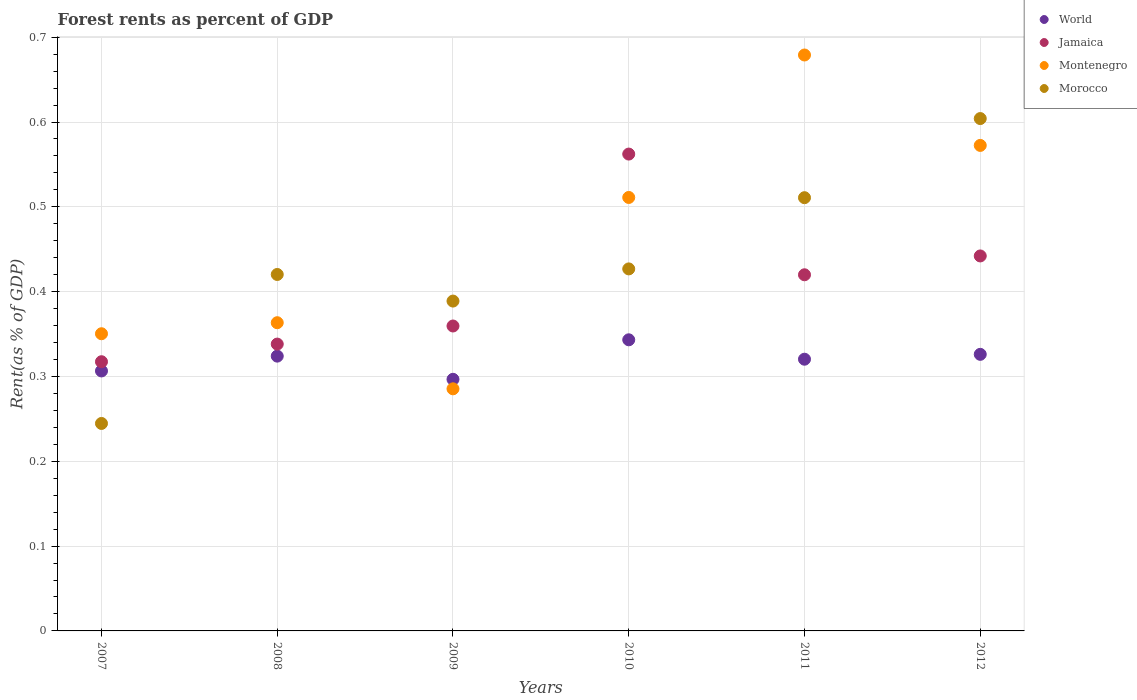How many different coloured dotlines are there?
Provide a succinct answer. 4. What is the forest rent in World in 2011?
Provide a succinct answer. 0.32. Across all years, what is the maximum forest rent in Jamaica?
Give a very brief answer. 0.56. Across all years, what is the minimum forest rent in Morocco?
Make the answer very short. 0.24. In which year was the forest rent in World minimum?
Offer a very short reply. 2009. What is the total forest rent in Jamaica in the graph?
Provide a short and direct response. 2.44. What is the difference between the forest rent in Jamaica in 2011 and that in 2012?
Your answer should be compact. -0.02. What is the difference between the forest rent in Montenegro in 2011 and the forest rent in Jamaica in 2010?
Make the answer very short. 0.12. What is the average forest rent in Morocco per year?
Offer a terse response. 0.43. In the year 2009, what is the difference between the forest rent in Montenegro and forest rent in World?
Ensure brevity in your answer.  -0.01. What is the ratio of the forest rent in World in 2007 to that in 2011?
Offer a very short reply. 0.96. Is the difference between the forest rent in Montenegro in 2008 and 2012 greater than the difference between the forest rent in World in 2008 and 2012?
Offer a very short reply. No. What is the difference between the highest and the second highest forest rent in World?
Provide a succinct answer. 0.02. What is the difference between the highest and the lowest forest rent in Jamaica?
Your answer should be compact. 0.24. Is it the case that in every year, the sum of the forest rent in World and forest rent in Montenegro  is greater than the sum of forest rent in Jamaica and forest rent in Morocco?
Give a very brief answer. No. Is it the case that in every year, the sum of the forest rent in Morocco and forest rent in Jamaica  is greater than the forest rent in Montenegro?
Provide a short and direct response. Yes. Is the forest rent in Morocco strictly greater than the forest rent in World over the years?
Offer a very short reply. No. Is the forest rent in Morocco strictly less than the forest rent in World over the years?
Offer a very short reply. No. How many dotlines are there?
Provide a short and direct response. 4. How many years are there in the graph?
Your answer should be very brief. 6. Does the graph contain grids?
Your answer should be very brief. Yes. What is the title of the graph?
Offer a terse response. Forest rents as percent of GDP. What is the label or title of the Y-axis?
Provide a short and direct response. Rent(as % of GDP). What is the Rent(as % of GDP) in World in 2007?
Your response must be concise. 0.31. What is the Rent(as % of GDP) of Jamaica in 2007?
Your answer should be very brief. 0.32. What is the Rent(as % of GDP) in Montenegro in 2007?
Keep it short and to the point. 0.35. What is the Rent(as % of GDP) of Morocco in 2007?
Keep it short and to the point. 0.24. What is the Rent(as % of GDP) in World in 2008?
Give a very brief answer. 0.32. What is the Rent(as % of GDP) in Jamaica in 2008?
Provide a succinct answer. 0.34. What is the Rent(as % of GDP) in Montenegro in 2008?
Give a very brief answer. 0.36. What is the Rent(as % of GDP) of Morocco in 2008?
Provide a short and direct response. 0.42. What is the Rent(as % of GDP) in World in 2009?
Give a very brief answer. 0.3. What is the Rent(as % of GDP) of Jamaica in 2009?
Provide a short and direct response. 0.36. What is the Rent(as % of GDP) in Montenegro in 2009?
Keep it short and to the point. 0.29. What is the Rent(as % of GDP) of Morocco in 2009?
Your response must be concise. 0.39. What is the Rent(as % of GDP) in World in 2010?
Your answer should be compact. 0.34. What is the Rent(as % of GDP) in Jamaica in 2010?
Make the answer very short. 0.56. What is the Rent(as % of GDP) of Montenegro in 2010?
Offer a very short reply. 0.51. What is the Rent(as % of GDP) of Morocco in 2010?
Provide a short and direct response. 0.43. What is the Rent(as % of GDP) of World in 2011?
Provide a short and direct response. 0.32. What is the Rent(as % of GDP) of Jamaica in 2011?
Give a very brief answer. 0.42. What is the Rent(as % of GDP) in Montenegro in 2011?
Your answer should be very brief. 0.68. What is the Rent(as % of GDP) in Morocco in 2011?
Provide a succinct answer. 0.51. What is the Rent(as % of GDP) of World in 2012?
Offer a terse response. 0.33. What is the Rent(as % of GDP) in Jamaica in 2012?
Your answer should be compact. 0.44. What is the Rent(as % of GDP) in Montenegro in 2012?
Offer a very short reply. 0.57. What is the Rent(as % of GDP) of Morocco in 2012?
Your answer should be compact. 0.6. Across all years, what is the maximum Rent(as % of GDP) of World?
Your response must be concise. 0.34. Across all years, what is the maximum Rent(as % of GDP) in Jamaica?
Keep it short and to the point. 0.56. Across all years, what is the maximum Rent(as % of GDP) of Montenegro?
Provide a succinct answer. 0.68. Across all years, what is the maximum Rent(as % of GDP) of Morocco?
Ensure brevity in your answer.  0.6. Across all years, what is the minimum Rent(as % of GDP) in World?
Provide a succinct answer. 0.3. Across all years, what is the minimum Rent(as % of GDP) of Jamaica?
Your response must be concise. 0.32. Across all years, what is the minimum Rent(as % of GDP) in Montenegro?
Make the answer very short. 0.29. Across all years, what is the minimum Rent(as % of GDP) in Morocco?
Provide a succinct answer. 0.24. What is the total Rent(as % of GDP) of World in the graph?
Your answer should be very brief. 1.92. What is the total Rent(as % of GDP) in Jamaica in the graph?
Your answer should be very brief. 2.44. What is the total Rent(as % of GDP) in Montenegro in the graph?
Provide a succinct answer. 2.76. What is the total Rent(as % of GDP) of Morocco in the graph?
Make the answer very short. 2.6. What is the difference between the Rent(as % of GDP) in World in 2007 and that in 2008?
Keep it short and to the point. -0.02. What is the difference between the Rent(as % of GDP) in Jamaica in 2007 and that in 2008?
Provide a short and direct response. -0.02. What is the difference between the Rent(as % of GDP) in Montenegro in 2007 and that in 2008?
Your answer should be very brief. -0.01. What is the difference between the Rent(as % of GDP) in Morocco in 2007 and that in 2008?
Your response must be concise. -0.18. What is the difference between the Rent(as % of GDP) in World in 2007 and that in 2009?
Your response must be concise. 0.01. What is the difference between the Rent(as % of GDP) of Jamaica in 2007 and that in 2009?
Offer a very short reply. -0.04. What is the difference between the Rent(as % of GDP) of Montenegro in 2007 and that in 2009?
Offer a terse response. 0.06. What is the difference between the Rent(as % of GDP) in Morocco in 2007 and that in 2009?
Make the answer very short. -0.14. What is the difference between the Rent(as % of GDP) in World in 2007 and that in 2010?
Your answer should be compact. -0.04. What is the difference between the Rent(as % of GDP) of Jamaica in 2007 and that in 2010?
Ensure brevity in your answer.  -0.24. What is the difference between the Rent(as % of GDP) of Montenegro in 2007 and that in 2010?
Provide a succinct answer. -0.16. What is the difference between the Rent(as % of GDP) in Morocco in 2007 and that in 2010?
Offer a terse response. -0.18. What is the difference between the Rent(as % of GDP) in World in 2007 and that in 2011?
Ensure brevity in your answer.  -0.01. What is the difference between the Rent(as % of GDP) in Jamaica in 2007 and that in 2011?
Your response must be concise. -0.1. What is the difference between the Rent(as % of GDP) in Montenegro in 2007 and that in 2011?
Offer a terse response. -0.33. What is the difference between the Rent(as % of GDP) of Morocco in 2007 and that in 2011?
Your answer should be very brief. -0.27. What is the difference between the Rent(as % of GDP) in World in 2007 and that in 2012?
Your answer should be very brief. -0.02. What is the difference between the Rent(as % of GDP) in Jamaica in 2007 and that in 2012?
Make the answer very short. -0.12. What is the difference between the Rent(as % of GDP) of Montenegro in 2007 and that in 2012?
Provide a succinct answer. -0.22. What is the difference between the Rent(as % of GDP) of Morocco in 2007 and that in 2012?
Offer a very short reply. -0.36. What is the difference between the Rent(as % of GDP) of World in 2008 and that in 2009?
Keep it short and to the point. 0.03. What is the difference between the Rent(as % of GDP) in Jamaica in 2008 and that in 2009?
Provide a short and direct response. -0.02. What is the difference between the Rent(as % of GDP) in Montenegro in 2008 and that in 2009?
Offer a terse response. 0.08. What is the difference between the Rent(as % of GDP) in Morocco in 2008 and that in 2009?
Offer a very short reply. 0.03. What is the difference between the Rent(as % of GDP) of World in 2008 and that in 2010?
Your response must be concise. -0.02. What is the difference between the Rent(as % of GDP) in Jamaica in 2008 and that in 2010?
Provide a short and direct response. -0.22. What is the difference between the Rent(as % of GDP) in Montenegro in 2008 and that in 2010?
Ensure brevity in your answer.  -0.15. What is the difference between the Rent(as % of GDP) in Morocco in 2008 and that in 2010?
Offer a very short reply. -0.01. What is the difference between the Rent(as % of GDP) in World in 2008 and that in 2011?
Make the answer very short. 0. What is the difference between the Rent(as % of GDP) in Jamaica in 2008 and that in 2011?
Provide a short and direct response. -0.08. What is the difference between the Rent(as % of GDP) of Montenegro in 2008 and that in 2011?
Provide a short and direct response. -0.32. What is the difference between the Rent(as % of GDP) of Morocco in 2008 and that in 2011?
Your answer should be very brief. -0.09. What is the difference between the Rent(as % of GDP) of World in 2008 and that in 2012?
Provide a short and direct response. -0. What is the difference between the Rent(as % of GDP) of Jamaica in 2008 and that in 2012?
Ensure brevity in your answer.  -0.1. What is the difference between the Rent(as % of GDP) of Montenegro in 2008 and that in 2012?
Give a very brief answer. -0.21. What is the difference between the Rent(as % of GDP) in Morocco in 2008 and that in 2012?
Make the answer very short. -0.18. What is the difference between the Rent(as % of GDP) in World in 2009 and that in 2010?
Offer a terse response. -0.05. What is the difference between the Rent(as % of GDP) of Jamaica in 2009 and that in 2010?
Your answer should be very brief. -0.2. What is the difference between the Rent(as % of GDP) in Montenegro in 2009 and that in 2010?
Provide a short and direct response. -0.23. What is the difference between the Rent(as % of GDP) of Morocco in 2009 and that in 2010?
Ensure brevity in your answer.  -0.04. What is the difference between the Rent(as % of GDP) of World in 2009 and that in 2011?
Your answer should be very brief. -0.02. What is the difference between the Rent(as % of GDP) in Jamaica in 2009 and that in 2011?
Ensure brevity in your answer.  -0.06. What is the difference between the Rent(as % of GDP) of Montenegro in 2009 and that in 2011?
Give a very brief answer. -0.39. What is the difference between the Rent(as % of GDP) of Morocco in 2009 and that in 2011?
Make the answer very short. -0.12. What is the difference between the Rent(as % of GDP) of World in 2009 and that in 2012?
Make the answer very short. -0.03. What is the difference between the Rent(as % of GDP) in Jamaica in 2009 and that in 2012?
Ensure brevity in your answer.  -0.08. What is the difference between the Rent(as % of GDP) in Montenegro in 2009 and that in 2012?
Offer a terse response. -0.29. What is the difference between the Rent(as % of GDP) of Morocco in 2009 and that in 2012?
Ensure brevity in your answer.  -0.22. What is the difference between the Rent(as % of GDP) in World in 2010 and that in 2011?
Your answer should be compact. 0.02. What is the difference between the Rent(as % of GDP) of Jamaica in 2010 and that in 2011?
Your response must be concise. 0.14. What is the difference between the Rent(as % of GDP) in Montenegro in 2010 and that in 2011?
Provide a short and direct response. -0.17. What is the difference between the Rent(as % of GDP) of Morocco in 2010 and that in 2011?
Give a very brief answer. -0.08. What is the difference between the Rent(as % of GDP) in World in 2010 and that in 2012?
Offer a very short reply. 0.02. What is the difference between the Rent(as % of GDP) in Jamaica in 2010 and that in 2012?
Ensure brevity in your answer.  0.12. What is the difference between the Rent(as % of GDP) in Montenegro in 2010 and that in 2012?
Offer a very short reply. -0.06. What is the difference between the Rent(as % of GDP) in Morocco in 2010 and that in 2012?
Provide a succinct answer. -0.18. What is the difference between the Rent(as % of GDP) of World in 2011 and that in 2012?
Keep it short and to the point. -0.01. What is the difference between the Rent(as % of GDP) of Jamaica in 2011 and that in 2012?
Provide a succinct answer. -0.02. What is the difference between the Rent(as % of GDP) of Montenegro in 2011 and that in 2012?
Offer a terse response. 0.11. What is the difference between the Rent(as % of GDP) in Morocco in 2011 and that in 2012?
Offer a terse response. -0.09. What is the difference between the Rent(as % of GDP) of World in 2007 and the Rent(as % of GDP) of Jamaica in 2008?
Your response must be concise. -0.03. What is the difference between the Rent(as % of GDP) in World in 2007 and the Rent(as % of GDP) in Montenegro in 2008?
Your answer should be compact. -0.06. What is the difference between the Rent(as % of GDP) of World in 2007 and the Rent(as % of GDP) of Morocco in 2008?
Offer a terse response. -0.11. What is the difference between the Rent(as % of GDP) in Jamaica in 2007 and the Rent(as % of GDP) in Montenegro in 2008?
Your response must be concise. -0.05. What is the difference between the Rent(as % of GDP) of Jamaica in 2007 and the Rent(as % of GDP) of Morocco in 2008?
Make the answer very short. -0.1. What is the difference between the Rent(as % of GDP) in Montenegro in 2007 and the Rent(as % of GDP) in Morocco in 2008?
Your answer should be compact. -0.07. What is the difference between the Rent(as % of GDP) of World in 2007 and the Rent(as % of GDP) of Jamaica in 2009?
Provide a succinct answer. -0.05. What is the difference between the Rent(as % of GDP) of World in 2007 and the Rent(as % of GDP) of Montenegro in 2009?
Keep it short and to the point. 0.02. What is the difference between the Rent(as % of GDP) of World in 2007 and the Rent(as % of GDP) of Morocco in 2009?
Offer a very short reply. -0.08. What is the difference between the Rent(as % of GDP) in Jamaica in 2007 and the Rent(as % of GDP) in Montenegro in 2009?
Your response must be concise. 0.03. What is the difference between the Rent(as % of GDP) in Jamaica in 2007 and the Rent(as % of GDP) in Morocco in 2009?
Your answer should be compact. -0.07. What is the difference between the Rent(as % of GDP) of Montenegro in 2007 and the Rent(as % of GDP) of Morocco in 2009?
Offer a terse response. -0.04. What is the difference between the Rent(as % of GDP) of World in 2007 and the Rent(as % of GDP) of Jamaica in 2010?
Make the answer very short. -0.26. What is the difference between the Rent(as % of GDP) of World in 2007 and the Rent(as % of GDP) of Montenegro in 2010?
Provide a succinct answer. -0.2. What is the difference between the Rent(as % of GDP) of World in 2007 and the Rent(as % of GDP) of Morocco in 2010?
Give a very brief answer. -0.12. What is the difference between the Rent(as % of GDP) in Jamaica in 2007 and the Rent(as % of GDP) in Montenegro in 2010?
Ensure brevity in your answer.  -0.19. What is the difference between the Rent(as % of GDP) in Jamaica in 2007 and the Rent(as % of GDP) in Morocco in 2010?
Your answer should be compact. -0.11. What is the difference between the Rent(as % of GDP) of Montenegro in 2007 and the Rent(as % of GDP) of Morocco in 2010?
Your response must be concise. -0.08. What is the difference between the Rent(as % of GDP) in World in 2007 and the Rent(as % of GDP) in Jamaica in 2011?
Offer a terse response. -0.11. What is the difference between the Rent(as % of GDP) in World in 2007 and the Rent(as % of GDP) in Montenegro in 2011?
Your answer should be compact. -0.37. What is the difference between the Rent(as % of GDP) of World in 2007 and the Rent(as % of GDP) of Morocco in 2011?
Keep it short and to the point. -0.2. What is the difference between the Rent(as % of GDP) in Jamaica in 2007 and the Rent(as % of GDP) in Montenegro in 2011?
Your response must be concise. -0.36. What is the difference between the Rent(as % of GDP) in Jamaica in 2007 and the Rent(as % of GDP) in Morocco in 2011?
Ensure brevity in your answer.  -0.19. What is the difference between the Rent(as % of GDP) in Montenegro in 2007 and the Rent(as % of GDP) in Morocco in 2011?
Give a very brief answer. -0.16. What is the difference between the Rent(as % of GDP) of World in 2007 and the Rent(as % of GDP) of Jamaica in 2012?
Ensure brevity in your answer.  -0.14. What is the difference between the Rent(as % of GDP) in World in 2007 and the Rent(as % of GDP) in Montenegro in 2012?
Give a very brief answer. -0.27. What is the difference between the Rent(as % of GDP) in World in 2007 and the Rent(as % of GDP) in Morocco in 2012?
Offer a terse response. -0.3. What is the difference between the Rent(as % of GDP) in Jamaica in 2007 and the Rent(as % of GDP) in Montenegro in 2012?
Your answer should be very brief. -0.26. What is the difference between the Rent(as % of GDP) in Jamaica in 2007 and the Rent(as % of GDP) in Morocco in 2012?
Ensure brevity in your answer.  -0.29. What is the difference between the Rent(as % of GDP) in Montenegro in 2007 and the Rent(as % of GDP) in Morocco in 2012?
Give a very brief answer. -0.25. What is the difference between the Rent(as % of GDP) of World in 2008 and the Rent(as % of GDP) of Jamaica in 2009?
Your answer should be compact. -0.04. What is the difference between the Rent(as % of GDP) of World in 2008 and the Rent(as % of GDP) of Montenegro in 2009?
Ensure brevity in your answer.  0.04. What is the difference between the Rent(as % of GDP) in World in 2008 and the Rent(as % of GDP) in Morocco in 2009?
Give a very brief answer. -0.06. What is the difference between the Rent(as % of GDP) of Jamaica in 2008 and the Rent(as % of GDP) of Montenegro in 2009?
Offer a very short reply. 0.05. What is the difference between the Rent(as % of GDP) in Jamaica in 2008 and the Rent(as % of GDP) in Morocco in 2009?
Provide a short and direct response. -0.05. What is the difference between the Rent(as % of GDP) of Montenegro in 2008 and the Rent(as % of GDP) of Morocco in 2009?
Provide a short and direct response. -0.03. What is the difference between the Rent(as % of GDP) of World in 2008 and the Rent(as % of GDP) of Jamaica in 2010?
Give a very brief answer. -0.24. What is the difference between the Rent(as % of GDP) of World in 2008 and the Rent(as % of GDP) of Montenegro in 2010?
Offer a very short reply. -0.19. What is the difference between the Rent(as % of GDP) in World in 2008 and the Rent(as % of GDP) in Morocco in 2010?
Ensure brevity in your answer.  -0.1. What is the difference between the Rent(as % of GDP) of Jamaica in 2008 and the Rent(as % of GDP) of Montenegro in 2010?
Give a very brief answer. -0.17. What is the difference between the Rent(as % of GDP) of Jamaica in 2008 and the Rent(as % of GDP) of Morocco in 2010?
Offer a terse response. -0.09. What is the difference between the Rent(as % of GDP) of Montenegro in 2008 and the Rent(as % of GDP) of Morocco in 2010?
Keep it short and to the point. -0.06. What is the difference between the Rent(as % of GDP) of World in 2008 and the Rent(as % of GDP) of Jamaica in 2011?
Make the answer very short. -0.1. What is the difference between the Rent(as % of GDP) in World in 2008 and the Rent(as % of GDP) in Montenegro in 2011?
Your answer should be very brief. -0.35. What is the difference between the Rent(as % of GDP) of World in 2008 and the Rent(as % of GDP) of Morocco in 2011?
Offer a very short reply. -0.19. What is the difference between the Rent(as % of GDP) in Jamaica in 2008 and the Rent(as % of GDP) in Montenegro in 2011?
Provide a succinct answer. -0.34. What is the difference between the Rent(as % of GDP) of Jamaica in 2008 and the Rent(as % of GDP) of Morocco in 2011?
Ensure brevity in your answer.  -0.17. What is the difference between the Rent(as % of GDP) of Montenegro in 2008 and the Rent(as % of GDP) of Morocco in 2011?
Keep it short and to the point. -0.15. What is the difference between the Rent(as % of GDP) in World in 2008 and the Rent(as % of GDP) in Jamaica in 2012?
Provide a short and direct response. -0.12. What is the difference between the Rent(as % of GDP) of World in 2008 and the Rent(as % of GDP) of Montenegro in 2012?
Give a very brief answer. -0.25. What is the difference between the Rent(as % of GDP) in World in 2008 and the Rent(as % of GDP) in Morocco in 2012?
Keep it short and to the point. -0.28. What is the difference between the Rent(as % of GDP) of Jamaica in 2008 and the Rent(as % of GDP) of Montenegro in 2012?
Provide a succinct answer. -0.23. What is the difference between the Rent(as % of GDP) in Jamaica in 2008 and the Rent(as % of GDP) in Morocco in 2012?
Your response must be concise. -0.27. What is the difference between the Rent(as % of GDP) of Montenegro in 2008 and the Rent(as % of GDP) of Morocco in 2012?
Your response must be concise. -0.24. What is the difference between the Rent(as % of GDP) in World in 2009 and the Rent(as % of GDP) in Jamaica in 2010?
Offer a terse response. -0.27. What is the difference between the Rent(as % of GDP) in World in 2009 and the Rent(as % of GDP) in Montenegro in 2010?
Give a very brief answer. -0.21. What is the difference between the Rent(as % of GDP) of World in 2009 and the Rent(as % of GDP) of Morocco in 2010?
Your answer should be very brief. -0.13. What is the difference between the Rent(as % of GDP) of Jamaica in 2009 and the Rent(as % of GDP) of Montenegro in 2010?
Your response must be concise. -0.15. What is the difference between the Rent(as % of GDP) of Jamaica in 2009 and the Rent(as % of GDP) of Morocco in 2010?
Keep it short and to the point. -0.07. What is the difference between the Rent(as % of GDP) of Montenegro in 2009 and the Rent(as % of GDP) of Morocco in 2010?
Keep it short and to the point. -0.14. What is the difference between the Rent(as % of GDP) in World in 2009 and the Rent(as % of GDP) in Jamaica in 2011?
Your answer should be compact. -0.12. What is the difference between the Rent(as % of GDP) of World in 2009 and the Rent(as % of GDP) of Montenegro in 2011?
Your answer should be very brief. -0.38. What is the difference between the Rent(as % of GDP) of World in 2009 and the Rent(as % of GDP) of Morocco in 2011?
Your answer should be compact. -0.21. What is the difference between the Rent(as % of GDP) in Jamaica in 2009 and the Rent(as % of GDP) in Montenegro in 2011?
Your response must be concise. -0.32. What is the difference between the Rent(as % of GDP) in Jamaica in 2009 and the Rent(as % of GDP) in Morocco in 2011?
Ensure brevity in your answer.  -0.15. What is the difference between the Rent(as % of GDP) in Montenegro in 2009 and the Rent(as % of GDP) in Morocco in 2011?
Give a very brief answer. -0.23. What is the difference between the Rent(as % of GDP) of World in 2009 and the Rent(as % of GDP) of Jamaica in 2012?
Provide a succinct answer. -0.15. What is the difference between the Rent(as % of GDP) in World in 2009 and the Rent(as % of GDP) in Montenegro in 2012?
Ensure brevity in your answer.  -0.28. What is the difference between the Rent(as % of GDP) of World in 2009 and the Rent(as % of GDP) of Morocco in 2012?
Ensure brevity in your answer.  -0.31. What is the difference between the Rent(as % of GDP) of Jamaica in 2009 and the Rent(as % of GDP) of Montenegro in 2012?
Give a very brief answer. -0.21. What is the difference between the Rent(as % of GDP) in Jamaica in 2009 and the Rent(as % of GDP) in Morocco in 2012?
Give a very brief answer. -0.24. What is the difference between the Rent(as % of GDP) in Montenegro in 2009 and the Rent(as % of GDP) in Morocco in 2012?
Ensure brevity in your answer.  -0.32. What is the difference between the Rent(as % of GDP) in World in 2010 and the Rent(as % of GDP) in Jamaica in 2011?
Offer a very short reply. -0.08. What is the difference between the Rent(as % of GDP) in World in 2010 and the Rent(as % of GDP) in Montenegro in 2011?
Give a very brief answer. -0.34. What is the difference between the Rent(as % of GDP) in World in 2010 and the Rent(as % of GDP) in Morocco in 2011?
Make the answer very short. -0.17. What is the difference between the Rent(as % of GDP) in Jamaica in 2010 and the Rent(as % of GDP) in Montenegro in 2011?
Offer a very short reply. -0.12. What is the difference between the Rent(as % of GDP) of Jamaica in 2010 and the Rent(as % of GDP) of Morocco in 2011?
Your answer should be very brief. 0.05. What is the difference between the Rent(as % of GDP) of Montenegro in 2010 and the Rent(as % of GDP) of Morocco in 2011?
Your answer should be very brief. 0. What is the difference between the Rent(as % of GDP) in World in 2010 and the Rent(as % of GDP) in Jamaica in 2012?
Make the answer very short. -0.1. What is the difference between the Rent(as % of GDP) in World in 2010 and the Rent(as % of GDP) in Montenegro in 2012?
Ensure brevity in your answer.  -0.23. What is the difference between the Rent(as % of GDP) in World in 2010 and the Rent(as % of GDP) in Morocco in 2012?
Provide a succinct answer. -0.26. What is the difference between the Rent(as % of GDP) of Jamaica in 2010 and the Rent(as % of GDP) of Montenegro in 2012?
Make the answer very short. -0.01. What is the difference between the Rent(as % of GDP) in Jamaica in 2010 and the Rent(as % of GDP) in Morocco in 2012?
Provide a succinct answer. -0.04. What is the difference between the Rent(as % of GDP) in Montenegro in 2010 and the Rent(as % of GDP) in Morocco in 2012?
Your answer should be compact. -0.09. What is the difference between the Rent(as % of GDP) of World in 2011 and the Rent(as % of GDP) of Jamaica in 2012?
Your answer should be compact. -0.12. What is the difference between the Rent(as % of GDP) of World in 2011 and the Rent(as % of GDP) of Montenegro in 2012?
Offer a very short reply. -0.25. What is the difference between the Rent(as % of GDP) in World in 2011 and the Rent(as % of GDP) in Morocco in 2012?
Make the answer very short. -0.28. What is the difference between the Rent(as % of GDP) in Jamaica in 2011 and the Rent(as % of GDP) in Montenegro in 2012?
Offer a very short reply. -0.15. What is the difference between the Rent(as % of GDP) in Jamaica in 2011 and the Rent(as % of GDP) in Morocco in 2012?
Provide a short and direct response. -0.18. What is the difference between the Rent(as % of GDP) of Montenegro in 2011 and the Rent(as % of GDP) of Morocco in 2012?
Keep it short and to the point. 0.07. What is the average Rent(as % of GDP) of World per year?
Ensure brevity in your answer.  0.32. What is the average Rent(as % of GDP) of Jamaica per year?
Provide a short and direct response. 0.41. What is the average Rent(as % of GDP) of Montenegro per year?
Offer a terse response. 0.46. What is the average Rent(as % of GDP) of Morocco per year?
Offer a terse response. 0.43. In the year 2007, what is the difference between the Rent(as % of GDP) of World and Rent(as % of GDP) of Jamaica?
Your answer should be compact. -0.01. In the year 2007, what is the difference between the Rent(as % of GDP) in World and Rent(as % of GDP) in Montenegro?
Give a very brief answer. -0.04. In the year 2007, what is the difference between the Rent(as % of GDP) in World and Rent(as % of GDP) in Morocco?
Give a very brief answer. 0.06. In the year 2007, what is the difference between the Rent(as % of GDP) in Jamaica and Rent(as % of GDP) in Montenegro?
Offer a terse response. -0.03. In the year 2007, what is the difference between the Rent(as % of GDP) of Jamaica and Rent(as % of GDP) of Morocco?
Offer a terse response. 0.07. In the year 2007, what is the difference between the Rent(as % of GDP) of Montenegro and Rent(as % of GDP) of Morocco?
Provide a succinct answer. 0.11. In the year 2008, what is the difference between the Rent(as % of GDP) of World and Rent(as % of GDP) of Jamaica?
Provide a succinct answer. -0.01. In the year 2008, what is the difference between the Rent(as % of GDP) in World and Rent(as % of GDP) in Montenegro?
Your response must be concise. -0.04. In the year 2008, what is the difference between the Rent(as % of GDP) in World and Rent(as % of GDP) in Morocco?
Your response must be concise. -0.1. In the year 2008, what is the difference between the Rent(as % of GDP) of Jamaica and Rent(as % of GDP) of Montenegro?
Your answer should be very brief. -0.03. In the year 2008, what is the difference between the Rent(as % of GDP) of Jamaica and Rent(as % of GDP) of Morocco?
Keep it short and to the point. -0.08. In the year 2008, what is the difference between the Rent(as % of GDP) in Montenegro and Rent(as % of GDP) in Morocco?
Your response must be concise. -0.06. In the year 2009, what is the difference between the Rent(as % of GDP) in World and Rent(as % of GDP) in Jamaica?
Your answer should be very brief. -0.06. In the year 2009, what is the difference between the Rent(as % of GDP) in World and Rent(as % of GDP) in Montenegro?
Provide a short and direct response. 0.01. In the year 2009, what is the difference between the Rent(as % of GDP) in World and Rent(as % of GDP) in Morocco?
Provide a succinct answer. -0.09. In the year 2009, what is the difference between the Rent(as % of GDP) of Jamaica and Rent(as % of GDP) of Montenegro?
Offer a very short reply. 0.07. In the year 2009, what is the difference between the Rent(as % of GDP) in Jamaica and Rent(as % of GDP) in Morocco?
Your answer should be very brief. -0.03. In the year 2009, what is the difference between the Rent(as % of GDP) of Montenegro and Rent(as % of GDP) of Morocco?
Your answer should be compact. -0.1. In the year 2010, what is the difference between the Rent(as % of GDP) in World and Rent(as % of GDP) in Jamaica?
Provide a short and direct response. -0.22. In the year 2010, what is the difference between the Rent(as % of GDP) of World and Rent(as % of GDP) of Montenegro?
Ensure brevity in your answer.  -0.17. In the year 2010, what is the difference between the Rent(as % of GDP) in World and Rent(as % of GDP) in Morocco?
Provide a short and direct response. -0.08. In the year 2010, what is the difference between the Rent(as % of GDP) in Jamaica and Rent(as % of GDP) in Montenegro?
Provide a succinct answer. 0.05. In the year 2010, what is the difference between the Rent(as % of GDP) in Jamaica and Rent(as % of GDP) in Morocco?
Your answer should be very brief. 0.14. In the year 2010, what is the difference between the Rent(as % of GDP) of Montenegro and Rent(as % of GDP) of Morocco?
Your answer should be very brief. 0.08. In the year 2011, what is the difference between the Rent(as % of GDP) of World and Rent(as % of GDP) of Jamaica?
Offer a terse response. -0.1. In the year 2011, what is the difference between the Rent(as % of GDP) in World and Rent(as % of GDP) in Montenegro?
Provide a short and direct response. -0.36. In the year 2011, what is the difference between the Rent(as % of GDP) of World and Rent(as % of GDP) of Morocco?
Your answer should be compact. -0.19. In the year 2011, what is the difference between the Rent(as % of GDP) of Jamaica and Rent(as % of GDP) of Montenegro?
Offer a terse response. -0.26. In the year 2011, what is the difference between the Rent(as % of GDP) in Jamaica and Rent(as % of GDP) in Morocco?
Provide a succinct answer. -0.09. In the year 2011, what is the difference between the Rent(as % of GDP) of Montenegro and Rent(as % of GDP) of Morocco?
Your response must be concise. 0.17. In the year 2012, what is the difference between the Rent(as % of GDP) in World and Rent(as % of GDP) in Jamaica?
Keep it short and to the point. -0.12. In the year 2012, what is the difference between the Rent(as % of GDP) of World and Rent(as % of GDP) of Montenegro?
Your answer should be very brief. -0.25. In the year 2012, what is the difference between the Rent(as % of GDP) in World and Rent(as % of GDP) in Morocco?
Offer a very short reply. -0.28. In the year 2012, what is the difference between the Rent(as % of GDP) of Jamaica and Rent(as % of GDP) of Montenegro?
Provide a short and direct response. -0.13. In the year 2012, what is the difference between the Rent(as % of GDP) in Jamaica and Rent(as % of GDP) in Morocco?
Offer a terse response. -0.16. In the year 2012, what is the difference between the Rent(as % of GDP) in Montenegro and Rent(as % of GDP) in Morocco?
Offer a very short reply. -0.03. What is the ratio of the Rent(as % of GDP) in World in 2007 to that in 2008?
Ensure brevity in your answer.  0.95. What is the ratio of the Rent(as % of GDP) of Jamaica in 2007 to that in 2008?
Your response must be concise. 0.94. What is the ratio of the Rent(as % of GDP) of Montenegro in 2007 to that in 2008?
Offer a terse response. 0.96. What is the ratio of the Rent(as % of GDP) of Morocco in 2007 to that in 2008?
Offer a terse response. 0.58. What is the ratio of the Rent(as % of GDP) of World in 2007 to that in 2009?
Your answer should be compact. 1.03. What is the ratio of the Rent(as % of GDP) in Jamaica in 2007 to that in 2009?
Provide a short and direct response. 0.88. What is the ratio of the Rent(as % of GDP) of Montenegro in 2007 to that in 2009?
Keep it short and to the point. 1.23. What is the ratio of the Rent(as % of GDP) of Morocco in 2007 to that in 2009?
Offer a very short reply. 0.63. What is the ratio of the Rent(as % of GDP) of World in 2007 to that in 2010?
Your response must be concise. 0.89. What is the ratio of the Rent(as % of GDP) of Jamaica in 2007 to that in 2010?
Your answer should be very brief. 0.56. What is the ratio of the Rent(as % of GDP) of Montenegro in 2007 to that in 2010?
Make the answer very short. 0.69. What is the ratio of the Rent(as % of GDP) in Morocco in 2007 to that in 2010?
Offer a very short reply. 0.57. What is the ratio of the Rent(as % of GDP) of World in 2007 to that in 2011?
Offer a terse response. 0.96. What is the ratio of the Rent(as % of GDP) in Jamaica in 2007 to that in 2011?
Provide a short and direct response. 0.76. What is the ratio of the Rent(as % of GDP) in Montenegro in 2007 to that in 2011?
Your response must be concise. 0.52. What is the ratio of the Rent(as % of GDP) in Morocco in 2007 to that in 2011?
Ensure brevity in your answer.  0.48. What is the ratio of the Rent(as % of GDP) of Jamaica in 2007 to that in 2012?
Your answer should be very brief. 0.72. What is the ratio of the Rent(as % of GDP) of Montenegro in 2007 to that in 2012?
Your answer should be very brief. 0.61. What is the ratio of the Rent(as % of GDP) of Morocco in 2007 to that in 2012?
Give a very brief answer. 0.4. What is the ratio of the Rent(as % of GDP) of World in 2008 to that in 2009?
Offer a very short reply. 1.09. What is the ratio of the Rent(as % of GDP) in Jamaica in 2008 to that in 2009?
Offer a very short reply. 0.94. What is the ratio of the Rent(as % of GDP) of Montenegro in 2008 to that in 2009?
Offer a terse response. 1.27. What is the ratio of the Rent(as % of GDP) in Morocco in 2008 to that in 2009?
Your answer should be compact. 1.08. What is the ratio of the Rent(as % of GDP) of World in 2008 to that in 2010?
Your answer should be very brief. 0.94. What is the ratio of the Rent(as % of GDP) of Jamaica in 2008 to that in 2010?
Offer a very short reply. 0.6. What is the ratio of the Rent(as % of GDP) in Montenegro in 2008 to that in 2010?
Make the answer very short. 0.71. What is the ratio of the Rent(as % of GDP) of Morocco in 2008 to that in 2010?
Your response must be concise. 0.98. What is the ratio of the Rent(as % of GDP) of World in 2008 to that in 2011?
Offer a terse response. 1.01. What is the ratio of the Rent(as % of GDP) in Jamaica in 2008 to that in 2011?
Offer a terse response. 0.81. What is the ratio of the Rent(as % of GDP) in Montenegro in 2008 to that in 2011?
Offer a very short reply. 0.54. What is the ratio of the Rent(as % of GDP) in Morocco in 2008 to that in 2011?
Keep it short and to the point. 0.82. What is the ratio of the Rent(as % of GDP) of World in 2008 to that in 2012?
Keep it short and to the point. 0.99. What is the ratio of the Rent(as % of GDP) in Jamaica in 2008 to that in 2012?
Your answer should be compact. 0.77. What is the ratio of the Rent(as % of GDP) of Montenegro in 2008 to that in 2012?
Your response must be concise. 0.63. What is the ratio of the Rent(as % of GDP) in Morocco in 2008 to that in 2012?
Offer a very short reply. 0.7. What is the ratio of the Rent(as % of GDP) in World in 2009 to that in 2010?
Offer a terse response. 0.86. What is the ratio of the Rent(as % of GDP) in Jamaica in 2009 to that in 2010?
Ensure brevity in your answer.  0.64. What is the ratio of the Rent(as % of GDP) in Montenegro in 2009 to that in 2010?
Your answer should be compact. 0.56. What is the ratio of the Rent(as % of GDP) of Morocco in 2009 to that in 2010?
Offer a terse response. 0.91. What is the ratio of the Rent(as % of GDP) of World in 2009 to that in 2011?
Keep it short and to the point. 0.93. What is the ratio of the Rent(as % of GDP) in Jamaica in 2009 to that in 2011?
Offer a terse response. 0.86. What is the ratio of the Rent(as % of GDP) of Montenegro in 2009 to that in 2011?
Keep it short and to the point. 0.42. What is the ratio of the Rent(as % of GDP) of Morocco in 2009 to that in 2011?
Your response must be concise. 0.76. What is the ratio of the Rent(as % of GDP) of World in 2009 to that in 2012?
Offer a very short reply. 0.91. What is the ratio of the Rent(as % of GDP) of Jamaica in 2009 to that in 2012?
Provide a short and direct response. 0.81. What is the ratio of the Rent(as % of GDP) of Montenegro in 2009 to that in 2012?
Keep it short and to the point. 0.5. What is the ratio of the Rent(as % of GDP) in Morocco in 2009 to that in 2012?
Your answer should be very brief. 0.64. What is the ratio of the Rent(as % of GDP) of World in 2010 to that in 2011?
Provide a short and direct response. 1.07. What is the ratio of the Rent(as % of GDP) of Jamaica in 2010 to that in 2011?
Your response must be concise. 1.34. What is the ratio of the Rent(as % of GDP) in Montenegro in 2010 to that in 2011?
Your answer should be very brief. 0.75. What is the ratio of the Rent(as % of GDP) of Morocco in 2010 to that in 2011?
Keep it short and to the point. 0.84. What is the ratio of the Rent(as % of GDP) in World in 2010 to that in 2012?
Your response must be concise. 1.05. What is the ratio of the Rent(as % of GDP) of Jamaica in 2010 to that in 2012?
Ensure brevity in your answer.  1.27. What is the ratio of the Rent(as % of GDP) of Montenegro in 2010 to that in 2012?
Provide a short and direct response. 0.89. What is the ratio of the Rent(as % of GDP) in Morocco in 2010 to that in 2012?
Make the answer very short. 0.71. What is the ratio of the Rent(as % of GDP) of World in 2011 to that in 2012?
Offer a very short reply. 0.98. What is the ratio of the Rent(as % of GDP) of Jamaica in 2011 to that in 2012?
Your answer should be very brief. 0.95. What is the ratio of the Rent(as % of GDP) of Montenegro in 2011 to that in 2012?
Your answer should be very brief. 1.19. What is the ratio of the Rent(as % of GDP) of Morocco in 2011 to that in 2012?
Offer a terse response. 0.85. What is the difference between the highest and the second highest Rent(as % of GDP) in World?
Your answer should be compact. 0.02. What is the difference between the highest and the second highest Rent(as % of GDP) in Jamaica?
Ensure brevity in your answer.  0.12. What is the difference between the highest and the second highest Rent(as % of GDP) in Montenegro?
Keep it short and to the point. 0.11. What is the difference between the highest and the second highest Rent(as % of GDP) of Morocco?
Your response must be concise. 0.09. What is the difference between the highest and the lowest Rent(as % of GDP) of World?
Give a very brief answer. 0.05. What is the difference between the highest and the lowest Rent(as % of GDP) of Jamaica?
Offer a terse response. 0.24. What is the difference between the highest and the lowest Rent(as % of GDP) of Montenegro?
Ensure brevity in your answer.  0.39. What is the difference between the highest and the lowest Rent(as % of GDP) in Morocco?
Your answer should be very brief. 0.36. 